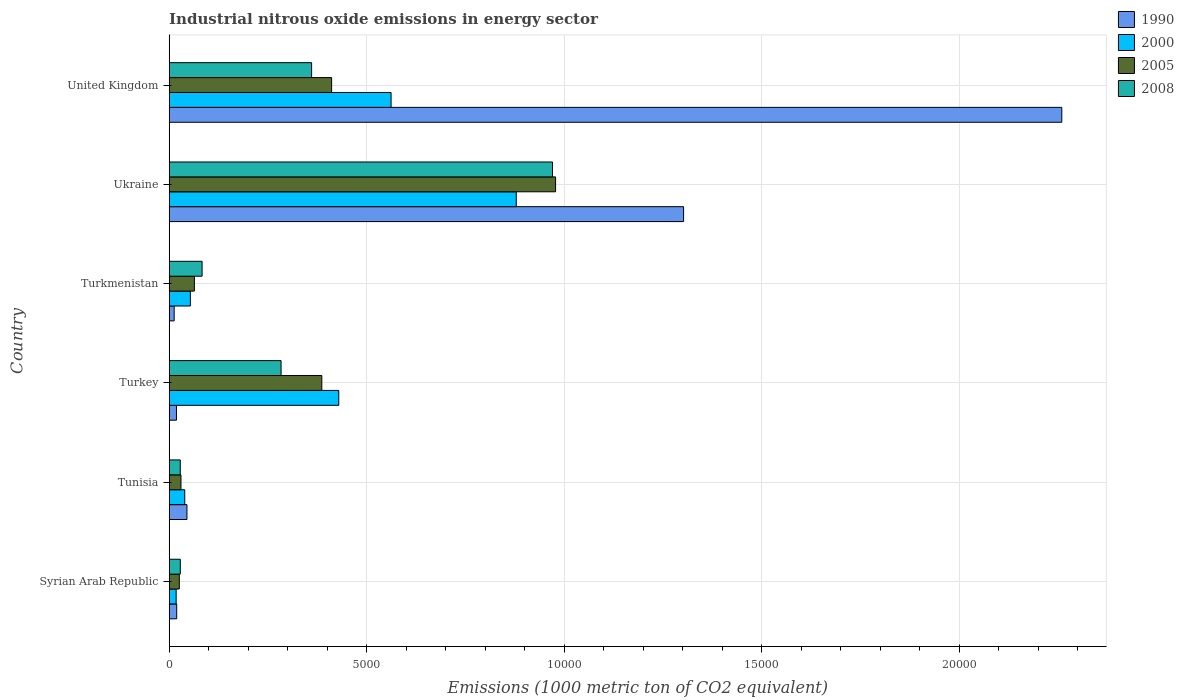How many groups of bars are there?
Your answer should be very brief. 6. Are the number of bars on each tick of the Y-axis equal?
Ensure brevity in your answer.  Yes. What is the label of the 5th group of bars from the top?
Provide a succinct answer. Tunisia. What is the amount of industrial nitrous oxide emitted in 1990 in Tunisia?
Your answer should be very brief. 449.2. Across all countries, what is the maximum amount of industrial nitrous oxide emitted in 2005?
Give a very brief answer. 9779.9. Across all countries, what is the minimum amount of industrial nitrous oxide emitted in 2005?
Your answer should be very brief. 255.6. In which country was the amount of industrial nitrous oxide emitted in 2005 minimum?
Your response must be concise. Syrian Arab Republic. What is the total amount of industrial nitrous oxide emitted in 2000 in the graph?
Your answer should be compact. 1.98e+04. What is the difference between the amount of industrial nitrous oxide emitted in 1990 in Syrian Arab Republic and that in Turkey?
Offer a terse response. 6.1. What is the difference between the amount of industrial nitrous oxide emitted in 2008 in Syrian Arab Republic and the amount of industrial nitrous oxide emitted in 2005 in Ukraine?
Make the answer very short. -9499.2. What is the average amount of industrial nitrous oxide emitted in 2005 per country?
Offer a very short reply. 3157.38. What is the difference between the amount of industrial nitrous oxide emitted in 2000 and amount of industrial nitrous oxide emitted in 2005 in Ukraine?
Your answer should be compact. -995.1. In how many countries, is the amount of industrial nitrous oxide emitted in 2008 greater than 13000 1000 metric ton?
Make the answer very short. 0. What is the ratio of the amount of industrial nitrous oxide emitted in 2005 in Tunisia to that in Turkmenistan?
Keep it short and to the point. 0.47. What is the difference between the highest and the second highest amount of industrial nitrous oxide emitted in 2000?
Make the answer very short. 3168.8. What is the difference between the highest and the lowest amount of industrial nitrous oxide emitted in 1990?
Offer a very short reply. 2.25e+04. Is the sum of the amount of industrial nitrous oxide emitted in 2005 in Syrian Arab Republic and United Kingdom greater than the maximum amount of industrial nitrous oxide emitted in 1990 across all countries?
Keep it short and to the point. No. Is it the case that in every country, the sum of the amount of industrial nitrous oxide emitted in 2000 and amount of industrial nitrous oxide emitted in 1990 is greater than the sum of amount of industrial nitrous oxide emitted in 2005 and amount of industrial nitrous oxide emitted in 2008?
Your answer should be compact. No. What is the difference between two consecutive major ticks on the X-axis?
Keep it short and to the point. 5000. Are the values on the major ticks of X-axis written in scientific E-notation?
Your response must be concise. No. Where does the legend appear in the graph?
Keep it short and to the point. Top right. How are the legend labels stacked?
Keep it short and to the point. Vertical. What is the title of the graph?
Provide a succinct answer. Industrial nitrous oxide emissions in energy sector. What is the label or title of the X-axis?
Make the answer very short. Emissions (1000 metric ton of CO2 equivalent). What is the Emissions (1000 metric ton of CO2 equivalent) in 1990 in Syrian Arab Republic?
Offer a terse response. 189.7. What is the Emissions (1000 metric ton of CO2 equivalent) in 2000 in Syrian Arab Republic?
Your response must be concise. 175.8. What is the Emissions (1000 metric ton of CO2 equivalent) of 2005 in Syrian Arab Republic?
Offer a terse response. 255.6. What is the Emissions (1000 metric ton of CO2 equivalent) in 2008 in Syrian Arab Republic?
Keep it short and to the point. 280.7. What is the Emissions (1000 metric ton of CO2 equivalent) in 1990 in Tunisia?
Offer a terse response. 449.2. What is the Emissions (1000 metric ton of CO2 equivalent) in 2000 in Tunisia?
Your answer should be very brief. 393.4. What is the Emissions (1000 metric ton of CO2 equivalent) of 2005 in Tunisia?
Your answer should be compact. 297.7. What is the Emissions (1000 metric ton of CO2 equivalent) of 2008 in Tunisia?
Your answer should be compact. 279.8. What is the Emissions (1000 metric ton of CO2 equivalent) in 1990 in Turkey?
Keep it short and to the point. 183.6. What is the Emissions (1000 metric ton of CO2 equivalent) in 2000 in Turkey?
Provide a short and direct response. 4292. What is the Emissions (1000 metric ton of CO2 equivalent) of 2005 in Turkey?
Offer a very short reply. 3862.7. What is the Emissions (1000 metric ton of CO2 equivalent) in 2008 in Turkey?
Your response must be concise. 2831.3. What is the Emissions (1000 metric ton of CO2 equivalent) of 1990 in Turkmenistan?
Your answer should be very brief. 125.6. What is the Emissions (1000 metric ton of CO2 equivalent) of 2000 in Turkmenistan?
Keep it short and to the point. 535.7. What is the Emissions (1000 metric ton of CO2 equivalent) of 2005 in Turkmenistan?
Offer a very short reply. 637.2. What is the Emissions (1000 metric ton of CO2 equivalent) in 2008 in Turkmenistan?
Offer a very short reply. 832.5. What is the Emissions (1000 metric ton of CO2 equivalent) in 1990 in Ukraine?
Make the answer very short. 1.30e+04. What is the Emissions (1000 metric ton of CO2 equivalent) in 2000 in Ukraine?
Your answer should be compact. 8784.8. What is the Emissions (1000 metric ton of CO2 equivalent) of 2005 in Ukraine?
Your answer should be very brief. 9779.9. What is the Emissions (1000 metric ton of CO2 equivalent) in 2008 in Ukraine?
Make the answer very short. 9701.8. What is the Emissions (1000 metric ton of CO2 equivalent) in 1990 in United Kingdom?
Your answer should be very brief. 2.26e+04. What is the Emissions (1000 metric ton of CO2 equivalent) in 2000 in United Kingdom?
Your response must be concise. 5616. What is the Emissions (1000 metric ton of CO2 equivalent) of 2005 in United Kingdom?
Your answer should be very brief. 4111.2. What is the Emissions (1000 metric ton of CO2 equivalent) of 2008 in United Kingdom?
Offer a very short reply. 3604.6. Across all countries, what is the maximum Emissions (1000 metric ton of CO2 equivalent) in 1990?
Your response must be concise. 2.26e+04. Across all countries, what is the maximum Emissions (1000 metric ton of CO2 equivalent) of 2000?
Your answer should be very brief. 8784.8. Across all countries, what is the maximum Emissions (1000 metric ton of CO2 equivalent) of 2005?
Make the answer very short. 9779.9. Across all countries, what is the maximum Emissions (1000 metric ton of CO2 equivalent) in 2008?
Give a very brief answer. 9701.8. Across all countries, what is the minimum Emissions (1000 metric ton of CO2 equivalent) in 1990?
Provide a succinct answer. 125.6. Across all countries, what is the minimum Emissions (1000 metric ton of CO2 equivalent) of 2000?
Offer a very short reply. 175.8. Across all countries, what is the minimum Emissions (1000 metric ton of CO2 equivalent) of 2005?
Offer a terse response. 255.6. Across all countries, what is the minimum Emissions (1000 metric ton of CO2 equivalent) of 2008?
Provide a succinct answer. 279.8. What is the total Emissions (1000 metric ton of CO2 equivalent) in 1990 in the graph?
Keep it short and to the point. 3.66e+04. What is the total Emissions (1000 metric ton of CO2 equivalent) of 2000 in the graph?
Offer a terse response. 1.98e+04. What is the total Emissions (1000 metric ton of CO2 equivalent) in 2005 in the graph?
Keep it short and to the point. 1.89e+04. What is the total Emissions (1000 metric ton of CO2 equivalent) in 2008 in the graph?
Provide a succinct answer. 1.75e+04. What is the difference between the Emissions (1000 metric ton of CO2 equivalent) of 1990 in Syrian Arab Republic and that in Tunisia?
Ensure brevity in your answer.  -259.5. What is the difference between the Emissions (1000 metric ton of CO2 equivalent) of 2000 in Syrian Arab Republic and that in Tunisia?
Provide a short and direct response. -217.6. What is the difference between the Emissions (1000 metric ton of CO2 equivalent) in 2005 in Syrian Arab Republic and that in Tunisia?
Offer a very short reply. -42.1. What is the difference between the Emissions (1000 metric ton of CO2 equivalent) of 2000 in Syrian Arab Republic and that in Turkey?
Offer a terse response. -4116.2. What is the difference between the Emissions (1000 metric ton of CO2 equivalent) of 2005 in Syrian Arab Republic and that in Turkey?
Your answer should be compact. -3607.1. What is the difference between the Emissions (1000 metric ton of CO2 equivalent) of 2008 in Syrian Arab Republic and that in Turkey?
Provide a succinct answer. -2550.6. What is the difference between the Emissions (1000 metric ton of CO2 equivalent) in 1990 in Syrian Arab Republic and that in Turkmenistan?
Provide a succinct answer. 64.1. What is the difference between the Emissions (1000 metric ton of CO2 equivalent) in 2000 in Syrian Arab Republic and that in Turkmenistan?
Offer a very short reply. -359.9. What is the difference between the Emissions (1000 metric ton of CO2 equivalent) of 2005 in Syrian Arab Republic and that in Turkmenistan?
Make the answer very short. -381.6. What is the difference between the Emissions (1000 metric ton of CO2 equivalent) in 2008 in Syrian Arab Republic and that in Turkmenistan?
Your answer should be compact. -551.8. What is the difference between the Emissions (1000 metric ton of CO2 equivalent) of 1990 in Syrian Arab Republic and that in Ukraine?
Give a very brief answer. -1.28e+04. What is the difference between the Emissions (1000 metric ton of CO2 equivalent) of 2000 in Syrian Arab Republic and that in Ukraine?
Provide a short and direct response. -8609. What is the difference between the Emissions (1000 metric ton of CO2 equivalent) in 2005 in Syrian Arab Republic and that in Ukraine?
Offer a very short reply. -9524.3. What is the difference between the Emissions (1000 metric ton of CO2 equivalent) of 2008 in Syrian Arab Republic and that in Ukraine?
Ensure brevity in your answer.  -9421.1. What is the difference between the Emissions (1000 metric ton of CO2 equivalent) of 1990 in Syrian Arab Republic and that in United Kingdom?
Offer a very short reply. -2.24e+04. What is the difference between the Emissions (1000 metric ton of CO2 equivalent) of 2000 in Syrian Arab Republic and that in United Kingdom?
Ensure brevity in your answer.  -5440.2. What is the difference between the Emissions (1000 metric ton of CO2 equivalent) of 2005 in Syrian Arab Republic and that in United Kingdom?
Give a very brief answer. -3855.6. What is the difference between the Emissions (1000 metric ton of CO2 equivalent) in 2008 in Syrian Arab Republic and that in United Kingdom?
Your answer should be very brief. -3323.9. What is the difference between the Emissions (1000 metric ton of CO2 equivalent) of 1990 in Tunisia and that in Turkey?
Offer a terse response. 265.6. What is the difference between the Emissions (1000 metric ton of CO2 equivalent) of 2000 in Tunisia and that in Turkey?
Make the answer very short. -3898.6. What is the difference between the Emissions (1000 metric ton of CO2 equivalent) in 2005 in Tunisia and that in Turkey?
Offer a terse response. -3565. What is the difference between the Emissions (1000 metric ton of CO2 equivalent) of 2008 in Tunisia and that in Turkey?
Offer a terse response. -2551.5. What is the difference between the Emissions (1000 metric ton of CO2 equivalent) in 1990 in Tunisia and that in Turkmenistan?
Keep it short and to the point. 323.6. What is the difference between the Emissions (1000 metric ton of CO2 equivalent) of 2000 in Tunisia and that in Turkmenistan?
Offer a terse response. -142.3. What is the difference between the Emissions (1000 metric ton of CO2 equivalent) of 2005 in Tunisia and that in Turkmenistan?
Your answer should be very brief. -339.5. What is the difference between the Emissions (1000 metric ton of CO2 equivalent) in 2008 in Tunisia and that in Turkmenistan?
Ensure brevity in your answer.  -552.7. What is the difference between the Emissions (1000 metric ton of CO2 equivalent) in 1990 in Tunisia and that in Ukraine?
Your answer should be very brief. -1.26e+04. What is the difference between the Emissions (1000 metric ton of CO2 equivalent) of 2000 in Tunisia and that in Ukraine?
Provide a short and direct response. -8391.4. What is the difference between the Emissions (1000 metric ton of CO2 equivalent) of 2005 in Tunisia and that in Ukraine?
Your response must be concise. -9482.2. What is the difference between the Emissions (1000 metric ton of CO2 equivalent) in 2008 in Tunisia and that in Ukraine?
Make the answer very short. -9422. What is the difference between the Emissions (1000 metric ton of CO2 equivalent) in 1990 in Tunisia and that in United Kingdom?
Offer a terse response. -2.21e+04. What is the difference between the Emissions (1000 metric ton of CO2 equivalent) in 2000 in Tunisia and that in United Kingdom?
Provide a succinct answer. -5222.6. What is the difference between the Emissions (1000 metric ton of CO2 equivalent) in 2005 in Tunisia and that in United Kingdom?
Provide a short and direct response. -3813.5. What is the difference between the Emissions (1000 metric ton of CO2 equivalent) in 2008 in Tunisia and that in United Kingdom?
Give a very brief answer. -3324.8. What is the difference between the Emissions (1000 metric ton of CO2 equivalent) in 2000 in Turkey and that in Turkmenistan?
Offer a very short reply. 3756.3. What is the difference between the Emissions (1000 metric ton of CO2 equivalent) of 2005 in Turkey and that in Turkmenistan?
Provide a succinct answer. 3225.5. What is the difference between the Emissions (1000 metric ton of CO2 equivalent) of 2008 in Turkey and that in Turkmenistan?
Provide a succinct answer. 1998.8. What is the difference between the Emissions (1000 metric ton of CO2 equivalent) of 1990 in Turkey and that in Ukraine?
Provide a short and direct response. -1.28e+04. What is the difference between the Emissions (1000 metric ton of CO2 equivalent) of 2000 in Turkey and that in Ukraine?
Provide a succinct answer. -4492.8. What is the difference between the Emissions (1000 metric ton of CO2 equivalent) of 2005 in Turkey and that in Ukraine?
Offer a terse response. -5917.2. What is the difference between the Emissions (1000 metric ton of CO2 equivalent) of 2008 in Turkey and that in Ukraine?
Your answer should be compact. -6870.5. What is the difference between the Emissions (1000 metric ton of CO2 equivalent) of 1990 in Turkey and that in United Kingdom?
Provide a short and direct response. -2.24e+04. What is the difference between the Emissions (1000 metric ton of CO2 equivalent) in 2000 in Turkey and that in United Kingdom?
Your answer should be very brief. -1324. What is the difference between the Emissions (1000 metric ton of CO2 equivalent) of 2005 in Turkey and that in United Kingdom?
Give a very brief answer. -248.5. What is the difference between the Emissions (1000 metric ton of CO2 equivalent) in 2008 in Turkey and that in United Kingdom?
Give a very brief answer. -773.3. What is the difference between the Emissions (1000 metric ton of CO2 equivalent) of 1990 in Turkmenistan and that in Ukraine?
Your response must be concise. -1.29e+04. What is the difference between the Emissions (1000 metric ton of CO2 equivalent) in 2000 in Turkmenistan and that in Ukraine?
Provide a short and direct response. -8249.1. What is the difference between the Emissions (1000 metric ton of CO2 equivalent) of 2005 in Turkmenistan and that in Ukraine?
Your answer should be very brief. -9142.7. What is the difference between the Emissions (1000 metric ton of CO2 equivalent) of 2008 in Turkmenistan and that in Ukraine?
Make the answer very short. -8869.3. What is the difference between the Emissions (1000 metric ton of CO2 equivalent) in 1990 in Turkmenistan and that in United Kingdom?
Keep it short and to the point. -2.25e+04. What is the difference between the Emissions (1000 metric ton of CO2 equivalent) of 2000 in Turkmenistan and that in United Kingdom?
Your answer should be very brief. -5080.3. What is the difference between the Emissions (1000 metric ton of CO2 equivalent) of 2005 in Turkmenistan and that in United Kingdom?
Your answer should be very brief. -3474. What is the difference between the Emissions (1000 metric ton of CO2 equivalent) of 2008 in Turkmenistan and that in United Kingdom?
Offer a very short reply. -2772.1. What is the difference between the Emissions (1000 metric ton of CO2 equivalent) of 1990 in Ukraine and that in United Kingdom?
Give a very brief answer. -9573. What is the difference between the Emissions (1000 metric ton of CO2 equivalent) of 2000 in Ukraine and that in United Kingdom?
Ensure brevity in your answer.  3168.8. What is the difference between the Emissions (1000 metric ton of CO2 equivalent) in 2005 in Ukraine and that in United Kingdom?
Provide a succinct answer. 5668.7. What is the difference between the Emissions (1000 metric ton of CO2 equivalent) of 2008 in Ukraine and that in United Kingdom?
Provide a succinct answer. 6097.2. What is the difference between the Emissions (1000 metric ton of CO2 equivalent) in 1990 in Syrian Arab Republic and the Emissions (1000 metric ton of CO2 equivalent) in 2000 in Tunisia?
Your answer should be compact. -203.7. What is the difference between the Emissions (1000 metric ton of CO2 equivalent) in 1990 in Syrian Arab Republic and the Emissions (1000 metric ton of CO2 equivalent) in 2005 in Tunisia?
Offer a very short reply. -108. What is the difference between the Emissions (1000 metric ton of CO2 equivalent) in 1990 in Syrian Arab Republic and the Emissions (1000 metric ton of CO2 equivalent) in 2008 in Tunisia?
Offer a very short reply. -90.1. What is the difference between the Emissions (1000 metric ton of CO2 equivalent) of 2000 in Syrian Arab Republic and the Emissions (1000 metric ton of CO2 equivalent) of 2005 in Tunisia?
Provide a short and direct response. -121.9. What is the difference between the Emissions (1000 metric ton of CO2 equivalent) in 2000 in Syrian Arab Republic and the Emissions (1000 metric ton of CO2 equivalent) in 2008 in Tunisia?
Provide a short and direct response. -104. What is the difference between the Emissions (1000 metric ton of CO2 equivalent) of 2005 in Syrian Arab Republic and the Emissions (1000 metric ton of CO2 equivalent) of 2008 in Tunisia?
Provide a succinct answer. -24.2. What is the difference between the Emissions (1000 metric ton of CO2 equivalent) in 1990 in Syrian Arab Republic and the Emissions (1000 metric ton of CO2 equivalent) in 2000 in Turkey?
Provide a succinct answer. -4102.3. What is the difference between the Emissions (1000 metric ton of CO2 equivalent) of 1990 in Syrian Arab Republic and the Emissions (1000 metric ton of CO2 equivalent) of 2005 in Turkey?
Provide a short and direct response. -3673. What is the difference between the Emissions (1000 metric ton of CO2 equivalent) of 1990 in Syrian Arab Republic and the Emissions (1000 metric ton of CO2 equivalent) of 2008 in Turkey?
Your response must be concise. -2641.6. What is the difference between the Emissions (1000 metric ton of CO2 equivalent) in 2000 in Syrian Arab Republic and the Emissions (1000 metric ton of CO2 equivalent) in 2005 in Turkey?
Ensure brevity in your answer.  -3686.9. What is the difference between the Emissions (1000 metric ton of CO2 equivalent) in 2000 in Syrian Arab Republic and the Emissions (1000 metric ton of CO2 equivalent) in 2008 in Turkey?
Provide a short and direct response. -2655.5. What is the difference between the Emissions (1000 metric ton of CO2 equivalent) in 2005 in Syrian Arab Republic and the Emissions (1000 metric ton of CO2 equivalent) in 2008 in Turkey?
Provide a succinct answer. -2575.7. What is the difference between the Emissions (1000 metric ton of CO2 equivalent) of 1990 in Syrian Arab Republic and the Emissions (1000 metric ton of CO2 equivalent) of 2000 in Turkmenistan?
Offer a terse response. -346. What is the difference between the Emissions (1000 metric ton of CO2 equivalent) of 1990 in Syrian Arab Republic and the Emissions (1000 metric ton of CO2 equivalent) of 2005 in Turkmenistan?
Give a very brief answer. -447.5. What is the difference between the Emissions (1000 metric ton of CO2 equivalent) in 1990 in Syrian Arab Republic and the Emissions (1000 metric ton of CO2 equivalent) in 2008 in Turkmenistan?
Keep it short and to the point. -642.8. What is the difference between the Emissions (1000 metric ton of CO2 equivalent) in 2000 in Syrian Arab Republic and the Emissions (1000 metric ton of CO2 equivalent) in 2005 in Turkmenistan?
Give a very brief answer. -461.4. What is the difference between the Emissions (1000 metric ton of CO2 equivalent) in 2000 in Syrian Arab Republic and the Emissions (1000 metric ton of CO2 equivalent) in 2008 in Turkmenistan?
Make the answer very short. -656.7. What is the difference between the Emissions (1000 metric ton of CO2 equivalent) of 2005 in Syrian Arab Republic and the Emissions (1000 metric ton of CO2 equivalent) of 2008 in Turkmenistan?
Offer a very short reply. -576.9. What is the difference between the Emissions (1000 metric ton of CO2 equivalent) in 1990 in Syrian Arab Republic and the Emissions (1000 metric ton of CO2 equivalent) in 2000 in Ukraine?
Give a very brief answer. -8595.1. What is the difference between the Emissions (1000 metric ton of CO2 equivalent) in 1990 in Syrian Arab Republic and the Emissions (1000 metric ton of CO2 equivalent) in 2005 in Ukraine?
Provide a succinct answer. -9590.2. What is the difference between the Emissions (1000 metric ton of CO2 equivalent) of 1990 in Syrian Arab Republic and the Emissions (1000 metric ton of CO2 equivalent) of 2008 in Ukraine?
Provide a succinct answer. -9512.1. What is the difference between the Emissions (1000 metric ton of CO2 equivalent) in 2000 in Syrian Arab Republic and the Emissions (1000 metric ton of CO2 equivalent) in 2005 in Ukraine?
Keep it short and to the point. -9604.1. What is the difference between the Emissions (1000 metric ton of CO2 equivalent) of 2000 in Syrian Arab Republic and the Emissions (1000 metric ton of CO2 equivalent) of 2008 in Ukraine?
Keep it short and to the point. -9526. What is the difference between the Emissions (1000 metric ton of CO2 equivalent) of 2005 in Syrian Arab Republic and the Emissions (1000 metric ton of CO2 equivalent) of 2008 in Ukraine?
Make the answer very short. -9446.2. What is the difference between the Emissions (1000 metric ton of CO2 equivalent) of 1990 in Syrian Arab Republic and the Emissions (1000 metric ton of CO2 equivalent) of 2000 in United Kingdom?
Offer a terse response. -5426.3. What is the difference between the Emissions (1000 metric ton of CO2 equivalent) of 1990 in Syrian Arab Republic and the Emissions (1000 metric ton of CO2 equivalent) of 2005 in United Kingdom?
Provide a short and direct response. -3921.5. What is the difference between the Emissions (1000 metric ton of CO2 equivalent) of 1990 in Syrian Arab Republic and the Emissions (1000 metric ton of CO2 equivalent) of 2008 in United Kingdom?
Keep it short and to the point. -3414.9. What is the difference between the Emissions (1000 metric ton of CO2 equivalent) in 2000 in Syrian Arab Republic and the Emissions (1000 metric ton of CO2 equivalent) in 2005 in United Kingdom?
Provide a short and direct response. -3935.4. What is the difference between the Emissions (1000 metric ton of CO2 equivalent) in 2000 in Syrian Arab Republic and the Emissions (1000 metric ton of CO2 equivalent) in 2008 in United Kingdom?
Ensure brevity in your answer.  -3428.8. What is the difference between the Emissions (1000 metric ton of CO2 equivalent) of 2005 in Syrian Arab Republic and the Emissions (1000 metric ton of CO2 equivalent) of 2008 in United Kingdom?
Make the answer very short. -3349. What is the difference between the Emissions (1000 metric ton of CO2 equivalent) in 1990 in Tunisia and the Emissions (1000 metric ton of CO2 equivalent) in 2000 in Turkey?
Offer a terse response. -3842.8. What is the difference between the Emissions (1000 metric ton of CO2 equivalent) in 1990 in Tunisia and the Emissions (1000 metric ton of CO2 equivalent) in 2005 in Turkey?
Make the answer very short. -3413.5. What is the difference between the Emissions (1000 metric ton of CO2 equivalent) of 1990 in Tunisia and the Emissions (1000 metric ton of CO2 equivalent) of 2008 in Turkey?
Make the answer very short. -2382.1. What is the difference between the Emissions (1000 metric ton of CO2 equivalent) of 2000 in Tunisia and the Emissions (1000 metric ton of CO2 equivalent) of 2005 in Turkey?
Make the answer very short. -3469.3. What is the difference between the Emissions (1000 metric ton of CO2 equivalent) of 2000 in Tunisia and the Emissions (1000 metric ton of CO2 equivalent) of 2008 in Turkey?
Ensure brevity in your answer.  -2437.9. What is the difference between the Emissions (1000 metric ton of CO2 equivalent) in 2005 in Tunisia and the Emissions (1000 metric ton of CO2 equivalent) in 2008 in Turkey?
Provide a succinct answer. -2533.6. What is the difference between the Emissions (1000 metric ton of CO2 equivalent) in 1990 in Tunisia and the Emissions (1000 metric ton of CO2 equivalent) in 2000 in Turkmenistan?
Make the answer very short. -86.5. What is the difference between the Emissions (1000 metric ton of CO2 equivalent) of 1990 in Tunisia and the Emissions (1000 metric ton of CO2 equivalent) of 2005 in Turkmenistan?
Keep it short and to the point. -188. What is the difference between the Emissions (1000 metric ton of CO2 equivalent) in 1990 in Tunisia and the Emissions (1000 metric ton of CO2 equivalent) in 2008 in Turkmenistan?
Offer a very short reply. -383.3. What is the difference between the Emissions (1000 metric ton of CO2 equivalent) of 2000 in Tunisia and the Emissions (1000 metric ton of CO2 equivalent) of 2005 in Turkmenistan?
Your response must be concise. -243.8. What is the difference between the Emissions (1000 metric ton of CO2 equivalent) in 2000 in Tunisia and the Emissions (1000 metric ton of CO2 equivalent) in 2008 in Turkmenistan?
Provide a succinct answer. -439.1. What is the difference between the Emissions (1000 metric ton of CO2 equivalent) of 2005 in Tunisia and the Emissions (1000 metric ton of CO2 equivalent) of 2008 in Turkmenistan?
Offer a very short reply. -534.8. What is the difference between the Emissions (1000 metric ton of CO2 equivalent) of 1990 in Tunisia and the Emissions (1000 metric ton of CO2 equivalent) of 2000 in Ukraine?
Give a very brief answer. -8335.6. What is the difference between the Emissions (1000 metric ton of CO2 equivalent) of 1990 in Tunisia and the Emissions (1000 metric ton of CO2 equivalent) of 2005 in Ukraine?
Make the answer very short. -9330.7. What is the difference between the Emissions (1000 metric ton of CO2 equivalent) of 1990 in Tunisia and the Emissions (1000 metric ton of CO2 equivalent) of 2008 in Ukraine?
Ensure brevity in your answer.  -9252.6. What is the difference between the Emissions (1000 metric ton of CO2 equivalent) in 2000 in Tunisia and the Emissions (1000 metric ton of CO2 equivalent) in 2005 in Ukraine?
Your answer should be compact. -9386.5. What is the difference between the Emissions (1000 metric ton of CO2 equivalent) of 2000 in Tunisia and the Emissions (1000 metric ton of CO2 equivalent) of 2008 in Ukraine?
Your answer should be very brief. -9308.4. What is the difference between the Emissions (1000 metric ton of CO2 equivalent) in 2005 in Tunisia and the Emissions (1000 metric ton of CO2 equivalent) in 2008 in Ukraine?
Provide a short and direct response. -9404.1. What is the difference between the Emissions (1000 metric ton of CO2 equivalent) in 1990 in Tunisia and the Emissions (1000 metric ton of CO2 equivalent) in 2000 in United Kingdom?
Give a very brief answer. -5166.8. What is the difference between the Emissions (1000 metric ton of CO2 equivalent) in 1990 in Tunisia and the Emissions (1000 metric ton of CO2 equivalent) in 2005 in United Kingdom?
Offer a terse response. -3662. What is the difference between the Emissions (1000 metric ton of CO2 equivalent) in 1990 in Tunisia and the Emissions (1000 metric ton of CO2 equivalent) in 2008 in United Kingdom?
Make the answer very short. -3155.4. What is the difference between the Emissions (1000 metric ton of CO2 equivalent) of 2000 in Tunisia and the Emissions (1000 metric ton of CO2 equivalent) of 2005 in United Kingdom?
Your answer should be compact. -3717.8. What is the difference between the Emissions (1000 metric ton of CO2 equivalent) in 2000 in Tunisia and the Emissions (1000 metric ton of CO2 equivalent) in 2008 in United Kingdom?
Your answer should be very brief. -3211.2. What is the difference between the Emissions (1000 metric ton of CO2 equivalent) of 2005 in Tunisia and the Emissions (1000 metric ton of CO2 equivalent) of 2008 in United Kingdom?
Keep it short and to the point. -3306.9. What is the difference between the Emissions (1000 metric ton of CO2 equivalent) in 1990 in Turkey and the Emissions (1000 metric ton of CO2 equivalent) in 2000 in Turkmenistan?
Your answer should be very brief. -352.1. What is the difference between the Emissions (1000 metric ton of CO2 equivalent) in 1990 in Turkey and the Emissions (1000 metric ton of CO2 equivalent) in 2005 in Turkmenistan?
Give a very brief answer. -453.6. What is the difference between the Emissions (1000 metric ton of CO2 equivalent) of 1990 in Turkey and the Emissions (1000 metric ton of CO2 equivalent) of 2008 in Turkmenistan?
Make the answer very short. -648.9. What is the difference between the Emissions (1000 metric ton of CO2 equivalent) in 2000 in Turkey and the Emissions (1000 metric ton of CO2 equivalent) in 2005 in Turkmenistan?
Keep it short and to the point. 3654.8. What is the difference between the Emissions (1000 metric ton of CO2 equivalent) in 2000 in Turkey and the Emissions (1000 metric ton of CO2 equivalent) in 2008 in Turkmenistan?
Give a very brief answer. 3459.5. What is the difference between the Emissions (1000 metric ton of CO2 equivalent) in 2005 in Turkey and the Emissions (1000 metric ton of CO2 equivalent) in 2008 in Turkmenistan?
Your response must be concise. 3030.2. What is the difference between the Emissions (1000 metric ton of CO2 equivalent) of 1990 in Turkey and the Emissions (1000 metric ton of CO2 equivalent) of 2000 in Ukraine?
Your answer should be compact. -8601.2. What is the difference between the Emissions (1000 metric ton of CO2 equivalent) of 1990 in Turkey and the Emissions (1000 metric ton of CO2 equivalent) of 2005 in Ukraine?
Make the answer very short. -9596.3. What is the difference between the Emissions (1000 metric ton of CO2 equivalent) in 1990 in Turkey and the Emissions (1000 metric ton of CO2 equivalent) in 2008 in Ukraine?
Offer a very short reply. -9518.2. What is the difference between the Emissions (1000 metric ton of CO2 equivalent) of 2000 in Turkey and the Emissions (1000 metric ton of CO2 equivalent) of 2005 in Ukraine?
Ensure brevity in your answer.  -5487.9. What is the difference between the Emissions (1000 metric ton of CO2 equivalent) in 2000 in Turkey and the Emissions (1000 metric ton of CO2 equivalent) in 2008 in Ukraine?
Provide a succinct answer. -5409.8. What is the difference between the Emissions (1000 metric ton of CO2 equivalent) in 2005 in Turkey and the Emissions (1000 metric ton of CO2 equivalent) in 2008 in Ukraine?
Your answer should be compact. -5839.1. What is the difference between the Emissions (1000 metric ton of CO2 equivalent) in 1990 in Turkey and the Emissions (1000 metric ton of CO2 equivalent) in 2000 in United Kingdom?
Ensure brevity in your answer.  -5432.4. What is the difference between the Emissions (1000 metric ton of CO2 equivalent) in 1990 in Turkey and the Emissions (1000 metric ton of CO2 equivalent) in 2005 in United Kingdom?
Ensure brevity in your answer.  -3927.6. What is the difference between the Emissions (1000 metric ton of CO2 equivalent) of 1990 in Turkey and the Emissions (1000 metric ton of CO2 equivalent) of 2008 in United Kingdom?
Offer a terse response. -3421. What is the difference between the Emissions (1000 metric ton of CO2 equivalent) of 2000 in Turkey and the Emissions (1000 metric ton of CO2 equivalent) of 2005 in United Kingdom?
Keep it short and to the point. 180.8. What is the difference between the Emissions (1000 metric ton of CO2 equivalent) in 2000 in Turkey and the Emissions (1000 metric ton of CO2 equivalent) in 2008 in United Kingdom?
Ensure brevity in your answer.  687.4. What is the difference between the Emissions (1000 metric ton of CO2 equivalent) in 2005 in Turkey and the Emissions (1000 metric ton of CO2 equivalent) in 2008 in United Kingdom?
Ensure brevity in your answer.  258.1. What is the difference between the Emissions (1000 metric ton of CO2 equivalent) of 1990 in Turkmenistan and the Emissions (1000 metric ton of CO2 equivalent) of 2000 in Ukraine?
Give a very brief answer. -8659.2. What is the difference between the Emissions (1000 metric ton of CO2 equivalent) of 1990 in Turkmenistan and the Emissions (1000 metric ton of CO2 equivalent) of 2005 in Ukraine?
Provide a succinct answer. -9654.3. What is the difference between the Emissions (1000 metric ton of CO2 equivalent) of 1990 in Turkmenistan and the Emissions (1000 metric ton of CO2 equivalent) of 2008 in Ukraine?
Provide a short and direct response. -9576.2. What is the difference between the Emissions (1000 metric ton of CO2 equivalent) of 2000 in Turkmenistan and the Emissions (1000 metric ton of CO2 equivalent) of 2005 in Ukraine?
Your answer should be very brief. -9244.2. What is the difference between the Emissions (1000 metric ton of CO2 equivalent) of 2000 in Turkmenistan and the Emissions (1000 metric ton of CO2 equivalent) of 2008 in Ukraine?
Provide a succinct answer. -9166.1. What is the difference between the Emissions (1000 metric ton of CO2 equivalent) in 2005 in Turkmenistan and the Emissions (1000 metric ton of CO2 equivalent) in 2008 in Ukraine?
Give a very brief answer. -9064.6. What is the difference between the Emissions (1000 metric ton of CO2 equivalent) in 1990 in Turkmenistan and the Emissions (1000 metric ton of CO2 equivalent) in 2000 in United Kingdom?
Keep it short and to the point. -5490.4. What is the difference between the Emissions (1000 metric ton of CO2 equivalent) in 1990 in Turkmenistan and the Emissions (1000 metric ton of CO2 equivalent) in 2005 in United Kingdom?
Make the answer very short. -3985.6. What is the difference between the Emissions (1000 metric ton of CO2 equivalent) in 1990 in Turkmenistan and the Emissions (1000 metric ton of CO2 equivalent) in 2008 in United Kingdom?
Your response must be concise. -3479. What is the difference between the Emissions (1000 metric ton of CO2 equivalent) in 2000 in Turkmenistan and the Emissions (1000 metric ton of CO2 equivalent) in 2005 in United Kingdom?
Ensure brevity in your answer.  -3575.5. What is the difference between the Emissions (1000 metric ton of CO2 equivalent) of 2000 in Turkmenistan and the Emissions (1000 metric ton of CO2 equivalent) of 2008 in United Kingdom?
Provide a short and direct response. -3068.9. What is the difference between the Emissions (1000 metric ton of CO2 equivalent) in 2005 in Turkmenistan and the Emissions (1000 metric ton of CO2 equivalent) in 2008 in United Kingdom?
Provide a succinct answer. -2967.4. What is the difference between the Emissions (1000 metric ton of CO2 equivalent) in 1990 in Ukraine and the Emissions (1000 metric ton of CO2 equivalent) in 2000 in United Kingdom?
Your response must be concise. 7404. What is the difference between the Emissions (1000 metric ton of CO2 equivalent) of 1990 in Ukraine and the Emissions (1000 metric ton of CO2 equivalent) of 2005 in United Kingdom?
Provide a succinct answer. 8908.8. What is the difference between the Emissions (1000 metric ton of CO2 equivalent) in 1990 in Ukraine and the Emissions (1000 metric ton of CO2 equivalent) in 2008 in United Kingdom?
Keep it short and to the point. 9415.4. What is the difference between the Emissions (1000 metric ton of CO2 equivalent) in 2000 in Ukraine and the Emissions (1000 metric ton of CO2 equivalent) in 2005 in United Kingdom?
Offer a terse response. 4673.6. What is the difference between the Emissions (1000 metric ton of CO2 equivalent) in 2000 in Ukraine and the Emissions (1000 metric ton of CO2 equivalent) in 2008 in United Kingdom?
Offer a very short reply. 5180.2. What is the difference between the Emissions (1000 metric ton of CO2 equivalent) of 2005 in Ukraine and the Emissions (1000 metric ton of CO2 equivalent) of 2008 in United Kingdom?
Provide a succinct answer. 6175.3. What is the average Emissions (1000 metric ton of CO2 equivalent) of 1990 per country?
Offer a terse response. 6093.52. What is the average Emissions (1000 metric ton of CO2 equivalent) in 2000 per country?
Make the answer very short. 3299.62. What is the average Emissions (1000 metric ton of CO2 equivalent) in 2005 per country?
Your answer should be compact. 3157.38. What is the average Emissions (1000 metric ton of CO2 equivalent) in 2008 per country?
Your answer should be very brief. 2921.78. What is the difference between the Emissions (1000 metric ton of CO2 equivalent) of 1990 and Emissions (1000 metric ton of CO2 equivalent) of 2005 in Syrian Arab Republic?
Offer a terse response. -65.9. What is the difference between the Emissions (1000 metric ton of CO2 equivalent) in 1990 and Emissions (1000 metric ton of CO2 equivalent) in 2008 in Syrian Arab Republic?
Your response must be concise. -91. What is the difference between the Emissions (1000 metric ton of CO2 equivalent) in 2000 and Emissions (1000 metric ton of CO2 equivalent) in 2005 in Syrian Arab Republic?
Offer a very short reply. -79.8. What is the difference between the Emissions (1000 metric ton of CO2 equivalent) in 2000 and Emissions (1000 metric ton of CO2 equivalent) in 2008 in Syrian Arab Republic?
Provide a succinct answer. -104.9. What is the difference between the Emissions (1000 metric ton of CO2 equivalent) in 2005 and Emissions (1000 metric ton of CO2 equivalent) in 2008 in Syrian Arab Republic?
Provide a short and direct response. -25.1. What is the difference between the Emissions (1000 metric ton of CO2 equivalent) in 1990 and Emissions (1000 metric ton of CO2 equivalent) in 2000 in Tunisia?
Your answer should be very brief. 55.8. What is the difference between the Emissions (1000 metric ton of CO2 equivalent) of 1990 and Emissions (1000 metric ton of CO2 equivalent) of 2005 in Tunisia?
Offer a terse response. 151.5. What is the difference between the Emissions (1000 metric ton of CO2 equivalent) of 1990 and Emissions (1000 metric ton of CO2 equivalent) of 2008 in Tunisia?
Keep it short and to the point. 169.4. What is the difference between the Emissions (1000 metric ton of CO2 equivalent) in 2000 and Emissions (1000 metric ton of CO2 equivalent) in 2005 in Tunisia?
Your response must be concise. 95.7. What is the difference between the Emissions (1000 metric ton of CO2 equivalent) in 2000 and Emissions (1000 metric ton of CO2 equivalent) in 2008 in Tunisia?
Give a very brief answer. 113.6. What is the difference between the Emissions (1000 metric ton of CO2 equivalent) of 1990 and Emissions (1000 metric ton of CO2 equivalent) of 2000 in Turkey?
Offer a very short reply. -4108.4. What is the difference between the Emissions (1000 metric ton of CO2 equivalent) of 1990 and Emissions (1000 metric ton of CO2 equivalent) of 2005 in Turkey?
Offer a terse response. -3679.1. What is the difference between the Emissions (1000 metric ton of CO2 equivalent) of 1990 and Emissions (1000 metric ton of CO2 equivalent) of 2008 in Turkey?
Your answer should be compact. -2647.7. What is the difference between the Emissions (1000 metric ton of CO2 equivalent) in 2000 and Emissions (1000 metric ton of CO2 equivalent) in 2005 in Turkey?
Provide a short and direct response. 429.3. What is the difference between the Emissions (1000 metric ton of CO2 equivalent) in 2000 and Emissions (1000 metric ton of CO2 equivalent) in 2008 in Turkey?
Give a very brief answer. 1460.7. What is the difference between the Emissions (1000 metric ton of CO2 equivalent) of 2005 and Emissions (1000 metric ton of CO2 equivalent) of 2008 in Turkey?
Your response must be concise. 1031.4. What is the difference between the Emissions (1000 metric ton of CO2 equivalent) in 1990 and Emissions (1000 metric ton of CO2 equivalent) in 2000 in Turkmenistan?
Offer a very short reply. -410.1. What is the difference between the Emissions (1000 metric ton of CO2 equivalent) of 1990 and Emissions (1000 metric ton of CO2 equivalent) of 2005 in Turkmenistan?
Give a very brief answer. -511.6. What is the difference between the Emissions (1000 metric ton of CO2 equivalent) of 1990 and Emissions (1000 metric ton of CO2 equivalent) of 2008 in Turkmenistan?
Your response must be concise. -706.9. What is the difference between the Emissions (1000 metric ton of CO2 equivalent) of 2000 and Emissions (1000 metric ton of CO2 equivalent) of 2005 in Turkmenistan?
Offer a terse response. -101.5. What is the difference between the Emissions (1000 metric ton of CO2 equivalent) in 2000 and Emissions (1000 metric ton of CO2 equivalent) in 2008 in Turkmenistan?
Give a very brief answer. -296.8. What is the difference between the Emissions (1000 metric ton of CO2 equivalent) of 2005 and Emissions (1000 metric ton of CO2 equivalent) of 2008 in Turkmenistan?
Your answer should be compact. -195.3. What is the difference between the Emissions (1000 metric ton of CO2 equivalent) of 1990 and Emissions (1000 metric ton of CO2 equivalent) of 2000 in Ukraine?
Give a very brief answer. 4235.2. What is the difference between the Emissions (1000 metric ton of CO2 equivalent) of 1990 and Emissions (1000 metric ton of CO2 equivalent) of 2005 in Ukraine?
Offer a very short reply. 3240.1. What is the difference between the Emissions (1000 metric ton of CO2 equivalent) of 1990 and Emissions (1000 metric ton of CO2 equivalent) of 2008 in Ukraine?
Make the answer very short. 3318.2. What is the difference between the Emissions (1000 metric ton of CO2 equivalent) in 2000 and Emissions (1000 metric ton of CO2 equivalent) in 2005 in Ukraine?
Offer a terse response. -995.1. What is the difference between the Emissions (1000 metric ton of CO2 equivalent) in 2000 and Emissions (1000 metric ton of CO2 equivalent) in 2008 in Ukraine?
Provide a succinct answer. -917. What is the difference between the Emissions (1000 metric ton of CO2 equivalent) in 2005 and Emissions (1000 metric ton of CO2 equivalent) in 2008 in Ukraine?
Offer a terse response. 78.1. What is the difference between the Emissions (1000 metric ton of CO2 equivalent) of 1990 and Emissions (1000 metric ton of CO2 equivalent) of 2000 in United Kingdom?
Your answer should be very brief. 1.70e+04. What is the difference between the Emissions (1000 metric ton of CO2 equivalent) of 1990 and Emissions (1000 metric ton of CO2 equivalent) of 2005 in United Kingdom?
Keep it short and to the point. 1.85e+04. What is the difference between the Emissions (1000 metric ton of CO2 equivalent) of 1990 and Emissions (1000 metric ton of CO2 equivalent) of 2008 in United Kingdom?
Ensure brevity in your answer.  1.90e+04. What is the difference between the Emissions (1000 metric ton of CO2 equivalent) in 2000 and Emissions (1000 metric ton of CO2 equivalent) in 2005 in United Kingdom?
Keep it short and to the point. 1504.8. What is the difference between the Emissions (1000 metric ton of CO2 equivalent) in 2000 and Emissions (1000 metric ton of CO2 equivalent) in 2008 in United Kingdom?
Keep it short and to the point. 2011.4. What is the difference between the Emissions (1000 metric ton of CO2 equivalent) of 2005 and Emissions (1000 metric ton of CO2 equivalent) of 2008 in United Kingdom?
Your answer should be compact. 506.6. What is the ratio of the Emissions (1000 metric ton of CO2 equivalent) of 1990 in Syrian Arab Republic to that in Tunisia?
Your response must be concise. 0.42. What is the ratio of the Emissions (1000 metric ton of CO2 equivalent) of 2000 in Syrian Arab Republic to that in Tunisia?
Make the answer very short. 0.45. What is the ratio of the Emissions (1000 metric ton of CO2 equivalent) of 2005 in Syrian Arab Republic to that in Tunisia?
Give a very brief answer. 0.86. What is the ratio of the Emissions (1000 metric ton of CO2 equivalent) of 2008 in Syrian Arab Republic to that in Tunisia?
Your answer should be compact. 1. What is the ratio of the Emissions (1000 metric ton of CO2 equivalent) of 1990 in Syrian Arab Republic to that in Turkey?
Make the answer very short. 1.03. What is the ratio of the Emissions (1000 metric ton of CO2 equivalent) of 2000 in Syrian Arab Republic to that in Turkey?
Provide a short and direct response. 0.04. What is the ratio of the Emissions (1000 metric ton of CO2 equivalent) of 2005 in Syrian Arab Republic to that in Turkey?
Your response must be concise. 0.07. What is the ratio of the Emissions (1000 metric ton of CO2 equivalent) in 2008 in Syrian Arab Republic to that in Turkey?
Your answer should be very brief. 0.1. What is the ratio of the Emissions (1000 metric ton of CO2 equivalent) in 1990 in Syrian Arab Republic to that in Turkmenistan?
Your answer should be very brief. 1.51. What is the ratio of the Emissions (1000 metric ton of CO2 equivalent) of 2000 in Syrian Arab Republic to that in Turkmenistan?
Ensure brevity in your answer.  0.33. What is the ratio of the Emissions (1000 metric ton of CO2 equivalent) of 2005 in Syrian Arab Republic to that in Turkmenistan?
Provide a succinct answer. 0.4. What is the ratio of the Emissions (1000 metric ton of CO2 equivalent) of 2008 in Syrian Arab Republic to that in Turkmenistan?
Offer a terse response. 0.34. What is the ratio of the Emissions (1000 metric ton of CO2 equivalent) in 1990 in Syrian Arab Republic to that in Ukraine?
Ensure brevity in your answer.  0.01. What is the ratio of the Emissions (1000 metric ton of CO2 equivalent) in 2005 in Syrian Arab Republic to that in Ukraine?
Keep it short and to the point. 0.03. What is the ratio of the Emissions (1000 metric ton of CO2 equivalent) of 2008 in Syrian Arab Republic to that in Ukraine?
Your answer should be very brief. 0.03. What is the ratio of the Emissions (1000 metric ton of CO2 equivalent) of 1990 in Syrian Arab Republic to that in United Kingdom?
Offer a very short reply. 0.01. What is the ratio of the Emissions (1000 metric ton of CO2 equivalent) of 2000 in Syrian Arab Republic to that in United Kingdom?
Keep it short and to the point. 0.03. What is the ratio of the Emissions (1000 metric ton of CO2 equivalent) of 2005 in Syrian Arab Republic to that in United Kingdom?
Your response must be concise. 0.06. What is the ratio of the Emissions (1000 metric ton of CO2 equivalent) in 2008 in Syrian Arab Republic to that in United Kingdom?
Your answer should be compact. 0.08. What is the ratio of the Emissions (1000 metric ton of CO2 equivalent) of 1990 in Tunisia to that in Turkey?
Give a very brief answer. 2.45. What is the ratio of the Emissions (1000 metric ton of CO2 equivalent) of 2000 in Tunisia to that in Turkey?
Provide a short and direct response. 0.09. What is the ratio of the Emissions (1000 metric ton of CO2 equivalent) in 2005 in Tunisia to that in Turkey?
Give a very brief answer. 0.08. What is the ratio of the Emissions (1000 metric ton of CO2 equivalent) in 2008 in Tunisia to that in Turkey?
Give a very brief answer. 0.1. What is the ratio of the Emissions (1000 metric ton of CO2 equivalent) of 1990 in Tunisia to that in Turkmenistan?
Offer a terse response. 3.58. What is the ratio of the Emissions (1000 metric ton of CO2 equivalent) of 2000 in Tunisia to that in Turkmenistan?
Keep it short and to the point. 0.73. What is the ratio of the Emissions (1000 metric ton of CO2 equivalent) of 2005 in Tunisia to that in Turkmenistan?
Make the answer very short. 0.47. What is the ratio of the Emissions (1000 metric ton of CO2 equivalent) in 2008 in Tunisia to that in Turkmenistan?
Your answer should be very brief. 0.34. What is the ratio of the Emissions (1000 metric ton of CO2 equivalent) of 1990 in Tunisia to that in Ukraine?
Keep it short and to the point. 0.03. What is the ratio of the Emissions (1000 metric ton of CO2 equivalent) of 2000 in Tunisia to that in Ukraine?
Give a very brief answer. 0.04. What is the ratio of the Emissions (1000 metric ton of CO2 equivalent) of 2005 in Tunisia to that in Ukraine?
Offer a terse response. 0.03. What is the ratio of the Emissions (1000 metric ton of CO2 equivalent) in 2008 in Tunisia to that in Ukraine?
Provide a short and direct response. 0.03. What is the ratio of the Emissions (1000 metric ton of CO2 equivalent) in 1990 in Tunisia to that in United Kingdom?
Ensure brevity in your answer.  0.02. What is the ratio of the Emissions (1000 metric ton of CO2 equivalent) in 2000 in Tunisia to that in United Kingdom?
Make the answer very short. 0.07. What is the ratio of the Emissions (1000 metric ton of CO2 equivalent) in 2005 in Tunisia to that in United Kingdom?
Keep it short and to the point. 0.07. What is the ratio of the Emissions (1000 metric ton of CO2 equivalent) in 2008 in Tunisia to that in United Kingdom?
Keep it short and to the point. 0.08. What is the ratio of the Emissions (1000 metric ton of CO2 equivalent) in 1990 in Turkey to that in Turkmenistan?
Provide a short and direct response. 1.46. What is the ratio of the Emissions (1000 metric ton of CO2 equivalent) in 2000 in Turkey to that in Turkmenistan?
Make the answer very short. 8.01. What is the ratio of the Emissions (1000 metric ton of CO2 equivalent) in 2005 in Turkey to that in Turkmenistan?
Your response must be concise. 6.06. What is the ratio of the Emissions (1000 metric ton of CO2 equivalent) in 2008 in Turkey to that in Turkmenistan?
Offer a very short reply. 3.4. What is the ratio of the Emissions (1000 metric ton of CO2 equivalent) in 1990 in Turkey to that in Ukraine?
Offer a terse response. 0.01. What is the ratio of the Emissions (1000 metric ton of CO2 equivalent) of 2000 in Turkey to that in Ukraine?
Provide a short and direct response. 0.49. What is the ratio of the Emissions (1000 metric ton of CO2 equivalent) of 2005 in Turkey to that in Ukraine?
Your answer should be very brief. 0.4. What is the ratio of the Emissions (1000 metric ton of CO2 equivalent) in 2008 in Turkey to that in Ukraine?
Ensure brevity in your answer.  0.29. What is the ratio of the Emissions (1000 metric ton of CO2 equivalent) of 1990 in Turkey to that in United Kingdom?
Provide a short and direct response. 0.01. What is the ratio of the Emissions (1000 metric ton of CO2 equivalent) in 2000 in Turkey to that in United Kingdom?
Give a very brief answer. 0.76. What is the ratio of the Emissions (1000 metric ton of CO2 equivalent) in 2005 in Turkey to that in United Kingdom?
Provide a short and direct response. 0.94. What is the ratio of the Emissions (1000 metric ton of CO2 equivalent) in 2008 in Turkey to that in United Kingdom?
Offer a terse response. 0.79. What is the ratio of the Emissions (1000 metric ton of CO2 equivalent) in 1990 in Turkmenistan to that in Ukraine?
Your response must be concise. 0.01. What is the ratio of the Emissions (1000 metric ton of CO2 equivalent) of 2000 in Turkmenistan to that in Ukraine?
Make the answer very short. 0.06. What is the ratio of the Emissions (1000 metric ton of CO2 equivalent) in 2005 in Turkmenistan to that in Ukraine?
Your response must be concise. 0.07. What is the ratio of the Emissions (1000 metric ton of CO2 equivalent) of 2008 in Turkmenistan to that in Ukraine?
Provide a short and direct response. 0.09. What is the ratio of the Emissions (1000 metric ton of CO2 equivalent) of 1990 in Turkmenistan to that in United Kingdom?
Give a very brief answer. 0.01. What is the ratio of the Emissions (1000 metric ton of CO2 equivalent) in 2000 in Turkmenistan to that in United Kingdom?
Your answer should be compact. 0.1. What is the ratio of the Emissions (1000 metric ton of CO2 equivalent) of 2005 in Turkmenistan to that in United Kingdom?
Your answer should be very brief. 0.15. What is the ratio of the Emissions (1000 metric ton of CO2 equivalent) of 2008 in Turkmenistan to that in United Kingdom?
Offer a terse response. 0.23. What is the ratio of the Emissions (1000 metric ton of CO2 equivalent) in 1990 in Ukraine to that in United Kingdom?
Your answer should be compact. 0.58. What is the ratio of the Emissions (1000 metric ton of CO2 equivalent) of 2000 in Ukraine to that in United Kingdom?
Offer a very short reply. 1.56. What is the ratio of the Emissions (1000 metric ton of CO2 equivalent) of 2005 in Ukraine to that in United Kingdom?
Your response must be concise. 2.38. What is the ratio of the Emissions (1000 metric ton of CO2 equivalent) of 2008 in Ukraine to that in United Kingdom?
Your response must be concise. 2.69. What is the difference between the highest and the second highest Emissions (1000 metric ton of CO2 equivalent) of 1990?
Provide a short and direct response. 9573. What is the difference between the highest and the second highest Emissions (1000 metric ton of CO2 equivalent) in 2000?
Make the answer very short. 3168.8. What is the difference between the highest and the second highest Emissions (1000 metric ton of CO2 equivalent) of 2005?
Make the answer very short. 5668.7. What is the difference between the highest and the second highest Emissions (1000 metric ton of CO2 equivalent) of 2008?
Make the answer very short. 6097.2. What is the difference between the highest and the lowest Emissions (1000 metric ton of CO2 equivalent) of 1990?
Offer a very short reply. 2.25e+04. What is the difference between the highest and the lowest Emissions (1000 metric ton of CO2 equivalent) of 2000?
Make the answer very short. 8609. What is the difference between the highest and the lowest Emissions (1000 metric ton of CO2 equivalent) of 2005?
Your response must be concise. 9524.3. What is the difference between the highest and the lowest Emissions (1000 metric ton of CO2 equivalent) in 2008?
Ensure brevity in your answer.  9422. 